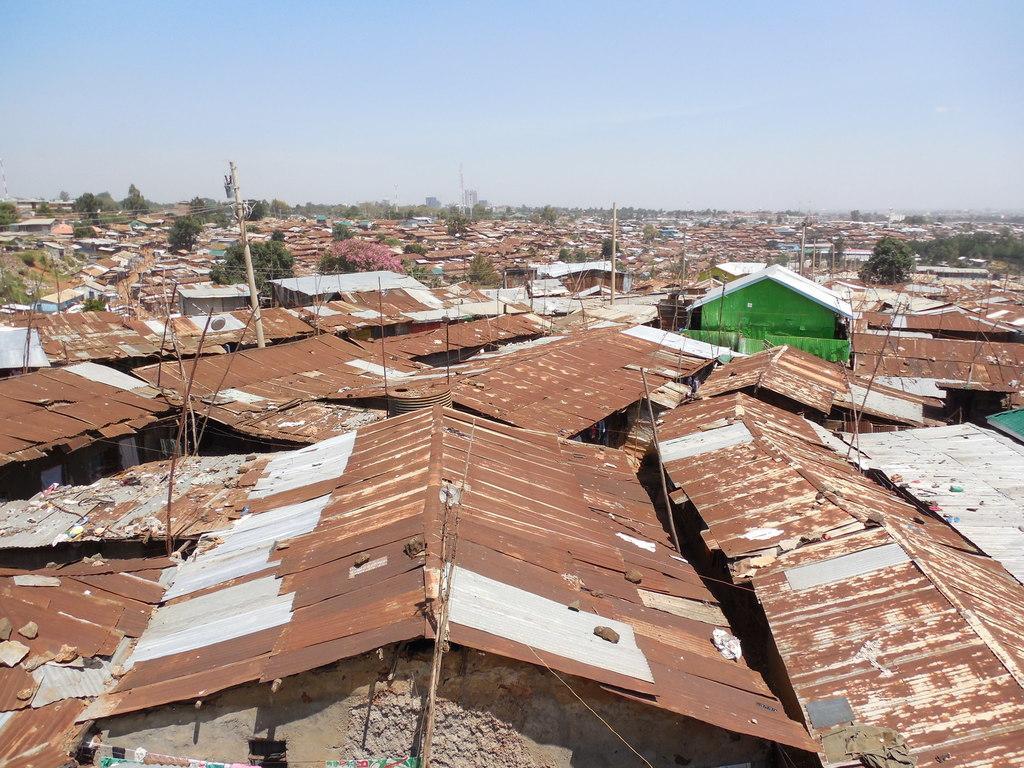Please provide a concise description of this image. This is the picture of the view of a place where we have some sheds, houses, trees and some poles. 